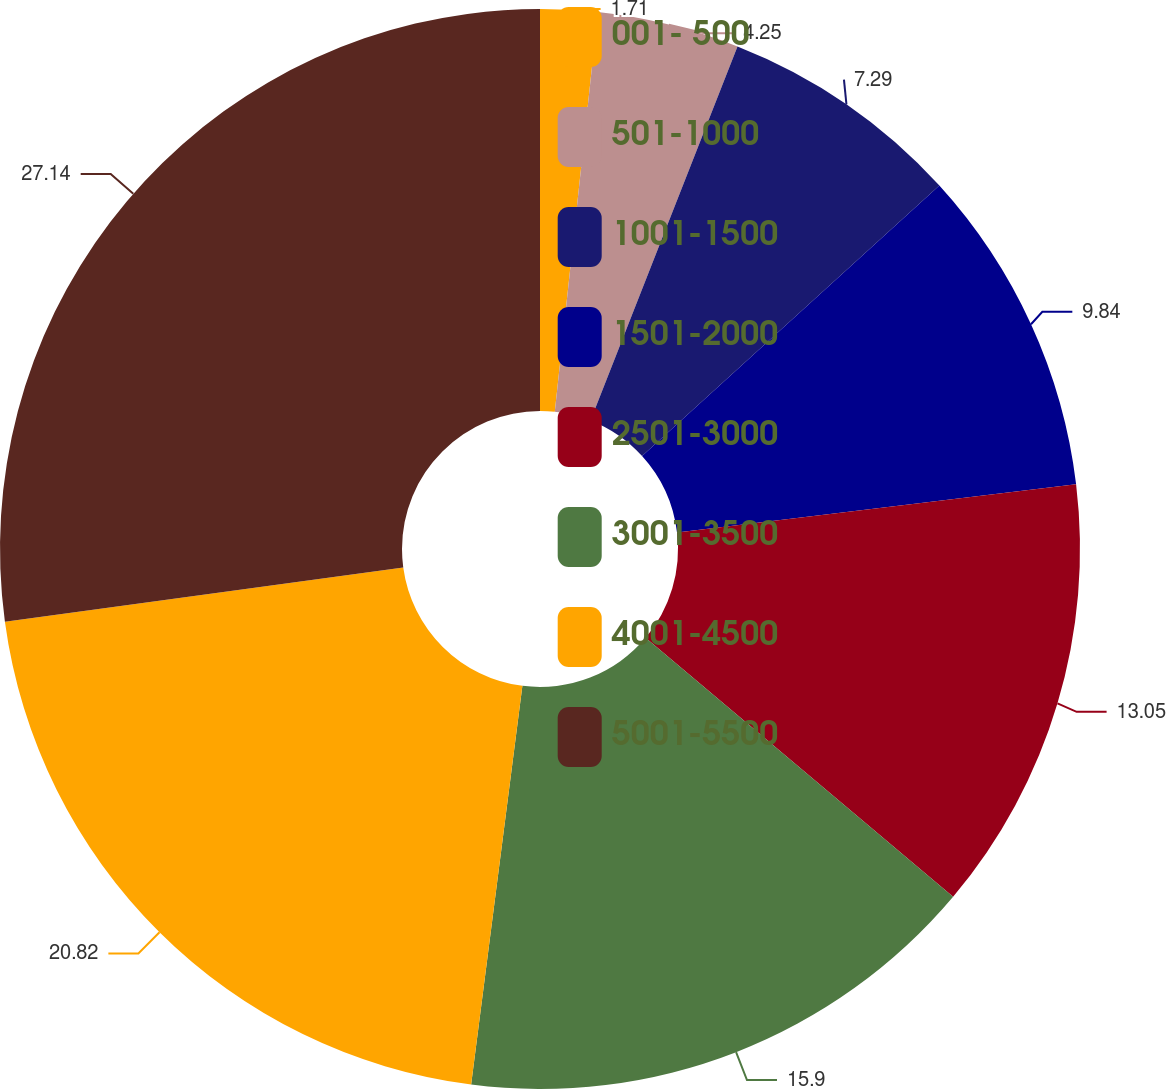<chart> <loc_0><loc_0><loc_500><loc_500><pie_chart><fcel>001- 500<fcel>501-1000<fcel>1001-1500<fcel>1501-2000<fcel>2501-3000<fcel>3001-3500<fcel>4001-4500<fcel>5001-5500<nl><fcel>1.71%<fcel>4.25%<fcel>7.29%<fcel>9.84%<fcel>13.05%<fcel>15.9%<fcel>20.82%<fcel>27.15%<nl></chart> 